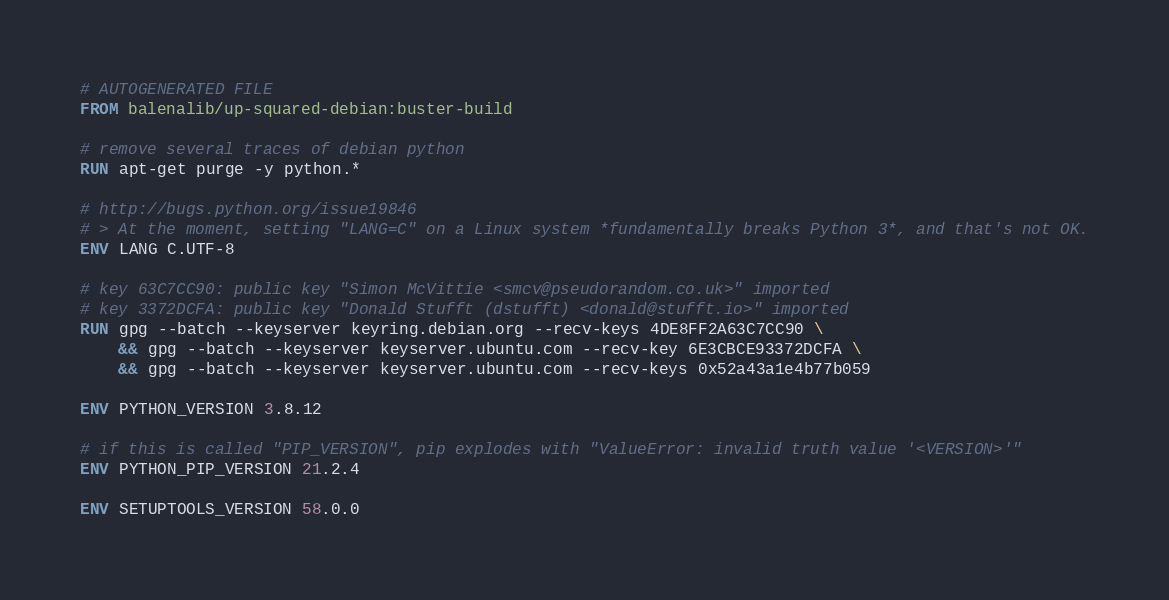Convert code to text. <code><loc_0><loc_0><loc_500><loc_500><_Dockerfile_># AUTOGENERATED FILE
FROM balenalib/up-squared-debian:buster-build

# remove several traces of debian python
RUN apt-get purge -y python.*

# http://bugs.python.org/issue19846
# > At the moment, setting "LANG=C" on a Linux system *fundamentally breaks Python 3*, and that's not OK.
ENV LANG C.UTF-8

# key 63C7CC90: public key "Simon McVittie <smcv@pseudorandom.co.uk>" imported
# key 3372DCFA: public key "Donald Stufft (dstufft) <donald@stufft.io>" imported
RUN gpg --batch --keyserver keyring.debian.org --recv-keys 4DE8FF2A63C7CC90 \
	&& gpg --batch --keyserver keyserver.ubuntu.com --recv-key 6E3CBCE93372DCFA \
	&& gpg --batch --keyserver keyserver.ubuntu.com --recv-keys 0x52a43a1e4b77b059

ENV PYTHON_VERSION 3.8.12

# if this is called "PIP_VERSION", pip explodes with "ValueError: invalid truth value '<VERSION>'"
ENV PYTHON_PIP_VERSION 21.2.4

ENV SETUPTOOLS_VERSION 58.0.0
</code> 